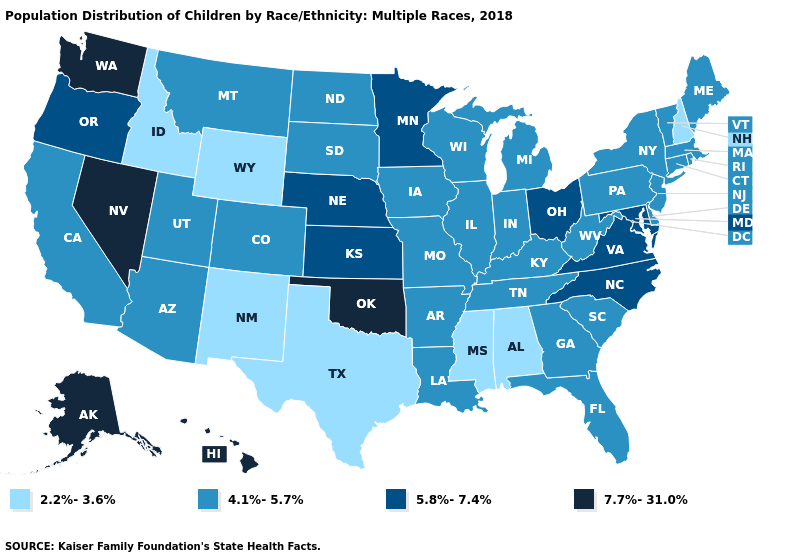Does Montana have a higher value than Mississippi?
Quick response, please. Yes. What is the value of Ohio?
Answer briefly. 5.8%-7.4%. What is the highest value in the USA?
Short answer required. 7.7%-31.0%. Among the states that border Mississippi , which have the lowest value?
Short answer required. Alabama. Among the states that border Connecticut , which have the highest value?
Concise answer only. Massachusetts, New York, Rhode Island. What is the lowest value in states that border Connecticut?
Keep it brief. 4.1%-5.7%. Name the states that have a value in the range 4.1%-5.7%?
Quick response, please. Arizona, Arkansas, California, Colorado, Connecticut, Delaware, Florida, Georgia, Illinois, Indiana, Iowa, Kentucky, Louisiana, Maine, Massachusetts, Michigan, Missouri, Montana, New Jersey, New York, North Dakota, Pennsylvania, Rhode Island, South Carolina, South Dakota, Tennessee, Utah, Vermont, West Virginia, Wisconsin. Among the states that border Washington , does Oregon have the highest value?
Answer briefly. Yes. What is the value of West Virginia?
Write a very short answer. 4.1%-5.7%. What is the value of Michigan?
Give a very brief answer. 4.1%-5.7%. Among the states that border Missouri , does Oklahoma have the highest value?
Keep it brief. Yes. Does Oregon have the lowest value in the USA?
Short answer required. No. Does Nevada have the highest value in the USA?
Short answer required. Yes. What is the value of California?
Give a very brief answer. 4.1%-5.7%. Which states hav the highest value in the West?
Concise answer only. Alaska, Hawaii, Nevada, Washington. 